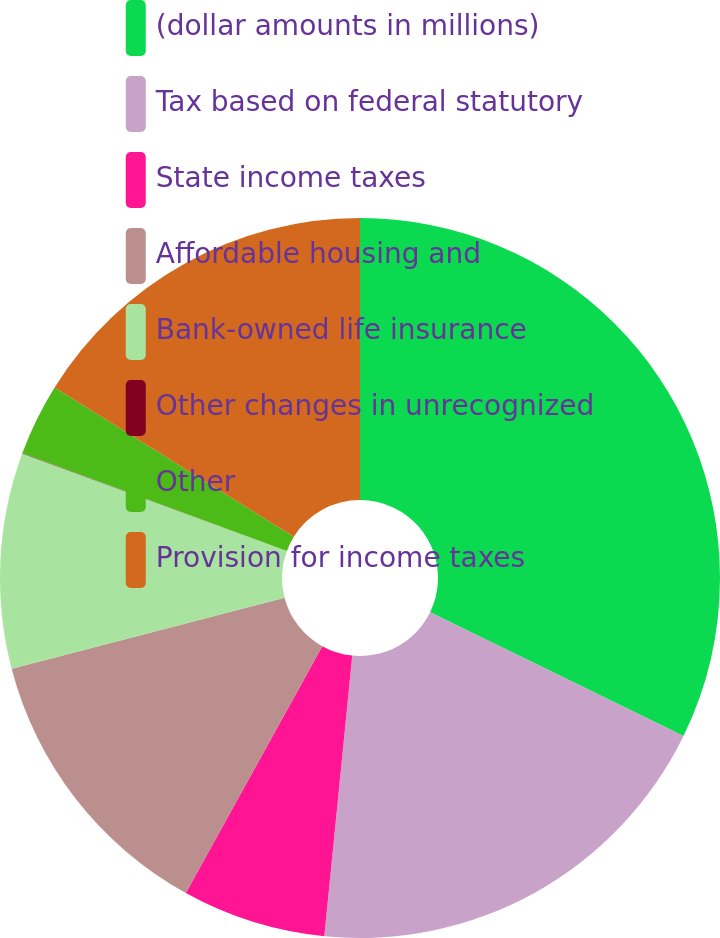Convert chart. <chart><loc_0><loc_0><loc_500><loc_500><pie_chart><fcel>(dollar amounts in millions)<fcel>Tax based on federal statutory<fcel>State income taxes<fcel>Affordable housing and<fcel>Bank-owned life insurance<fcel>Other changes in unrecognized<fcel>Other<fcel>Provision for income taxes<nl><fcel>32.23%<fcel>19.35%<fcel>6.46%<fcel>12.9%<fcel>9.68%<fcel>0.02%<fcel>3.24%<fcel>16.12%<nl></chart> 